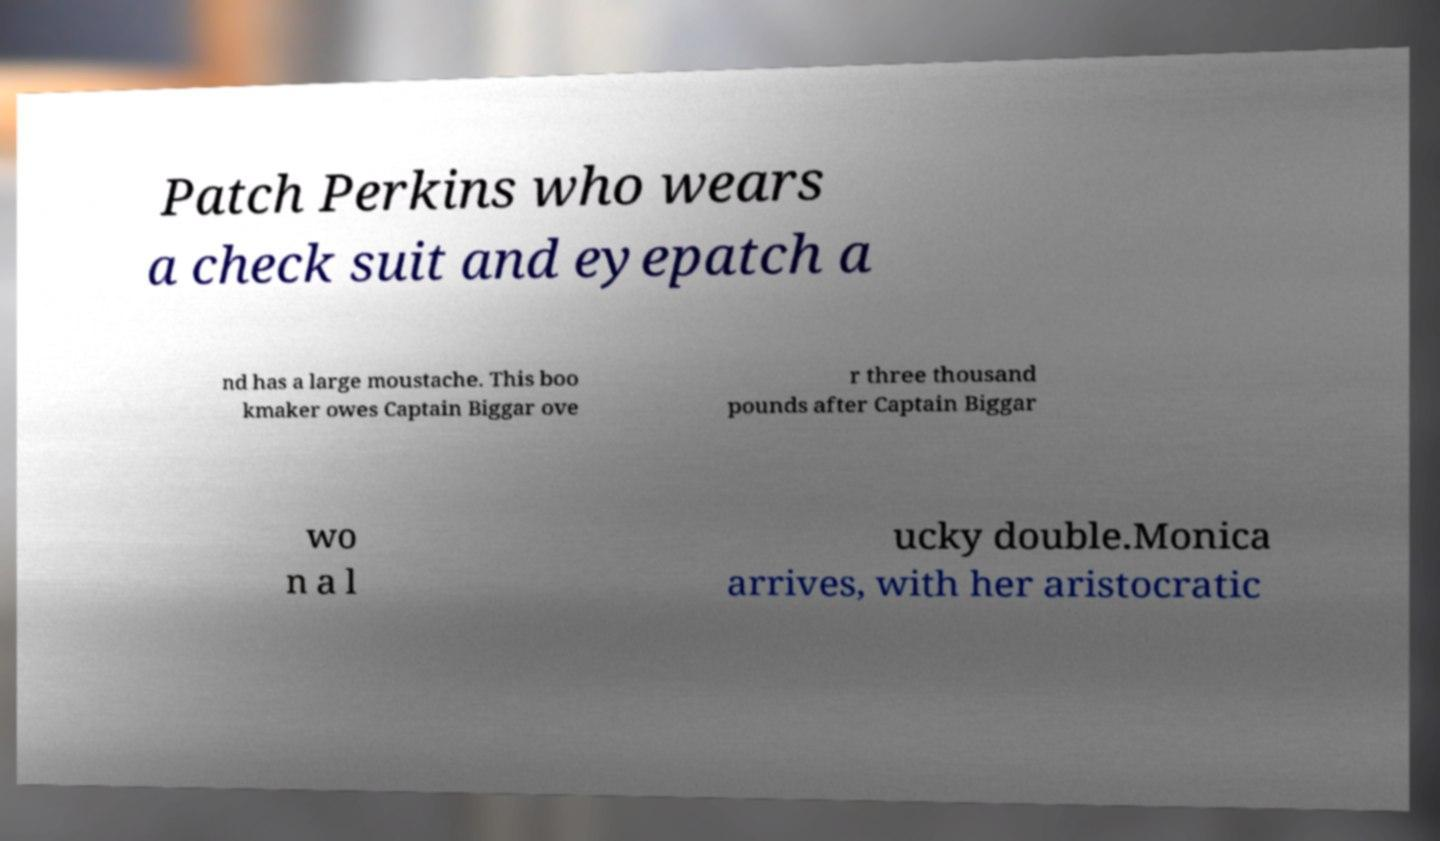There's text embedded in this image that I need extracted. Can you transcribe it verbatim? Patch Perkins who wears a check suit and eyepatch a nd has a large moustache. This boo kmaker owes Captain Biggar ove r three thousand pounds after Captain Biggar wo n a l ucky double.Monica arrives, with her aristocratic 